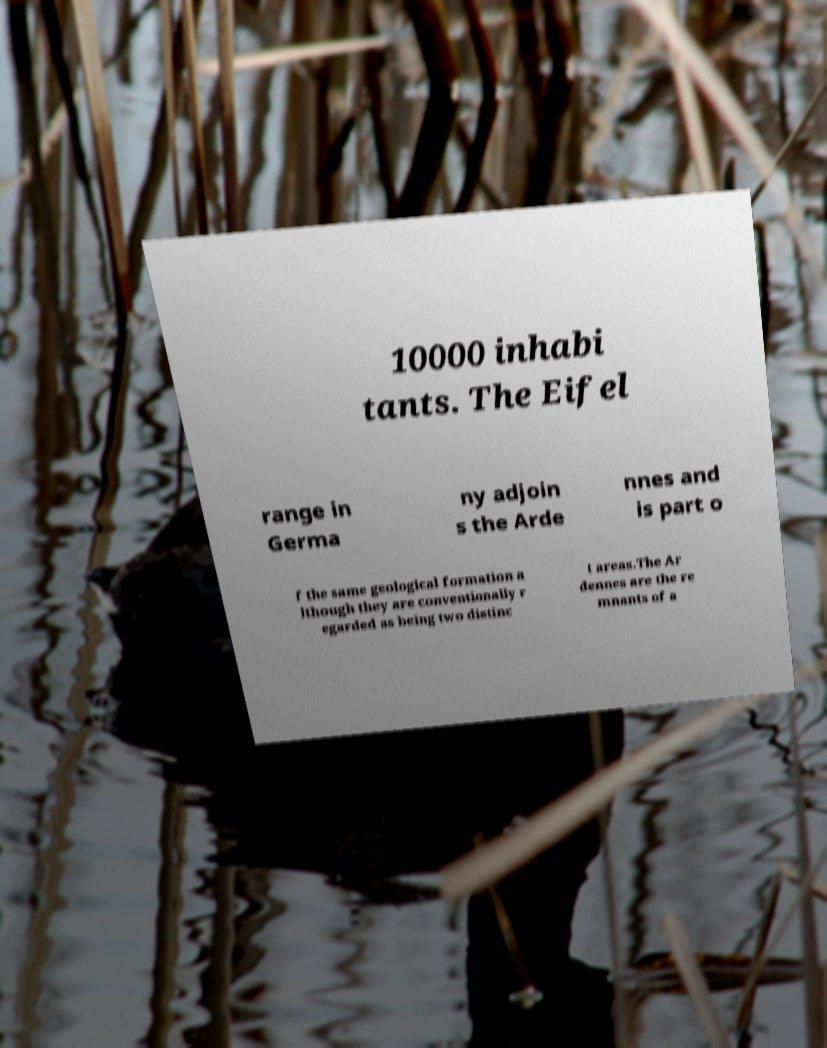Please read and relay the text visible in this image. What does it say? 10000 inhabi tants. The Eifel range in Germa ny adjoin s the Arde nnes and is part o f the same geological formation a lthough they are conventionally r egarded as being two distinc t areas.The Ar dennes are the re mnants of a 